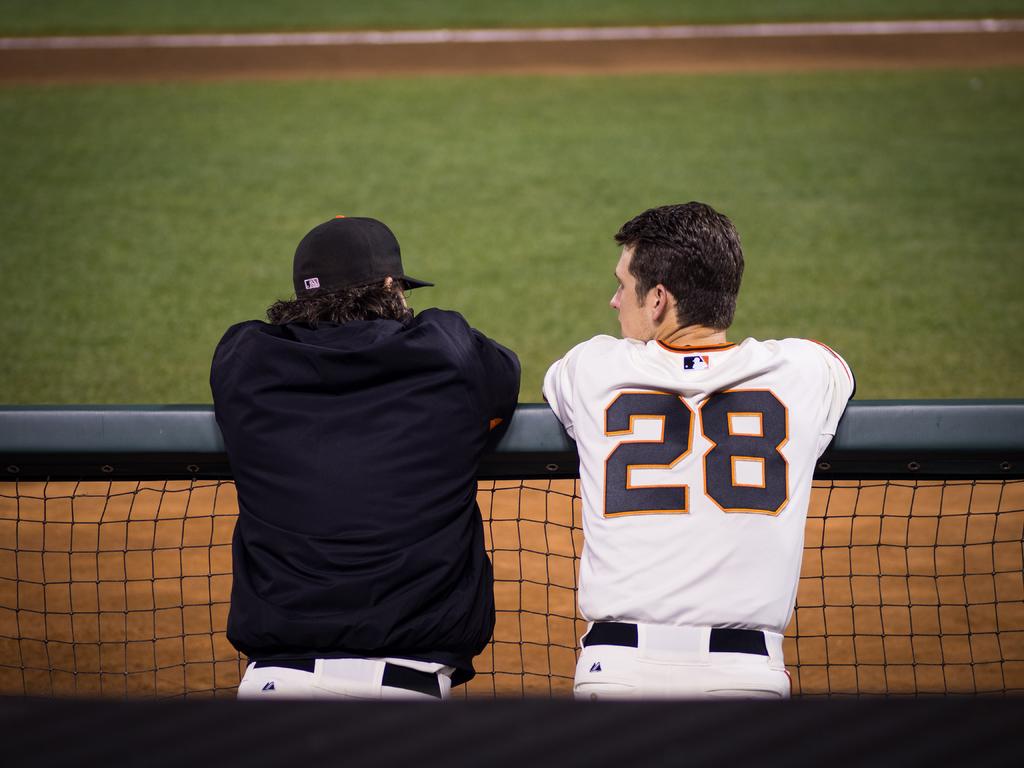What is the number on the back of his shirt?
Give a very brief answer. 28. 